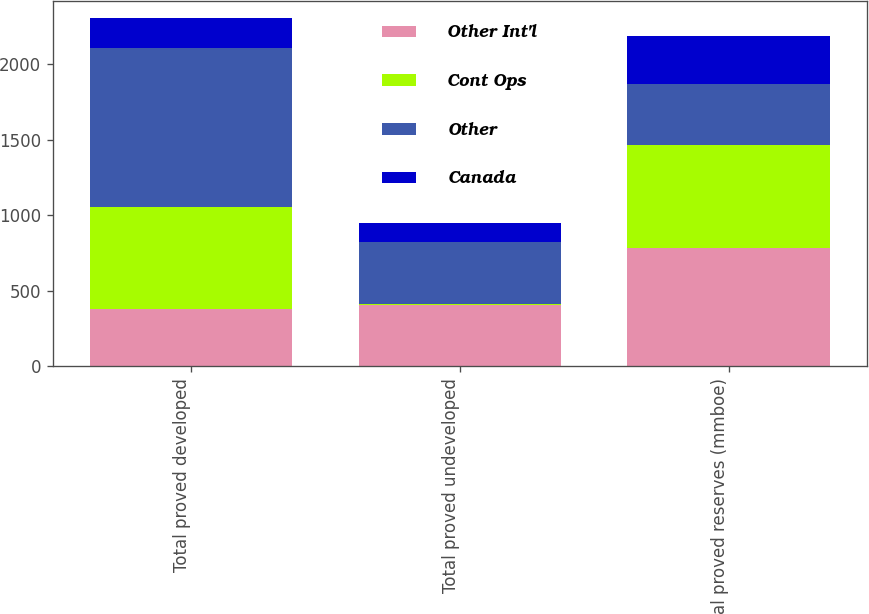<chart> <loc_0><loc_0><loc_500><loc_500><stacked_bar_chart><ecel><fcel>Total proved developed<fcel>Total proved undeveloped<fcel>Total proved reserves (mmboe)<nl><fcel>Other Int'l<fcel>382<fcel>405<fcel>787<nl><fcel>Cont Ops<fcel>674<fcel>6<fcel>680<nl><fcel>Other<fcel>1056<fcel>411<fcel>405<nl><fcel>Canada<fcel>193<fcel>125<fcel>318<nl></chart> 